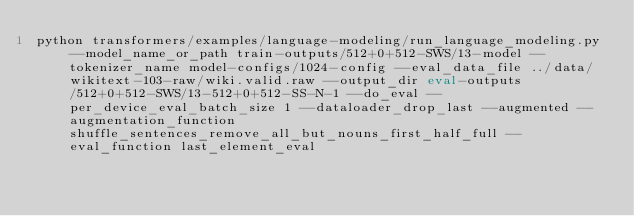<code> <loc_0><loc_0><loc_500><loc_500><_Bash_>python transformers/examples/language-modeling/run_language_modeling.py --model_name_or_path train-outputs/512+0+512-SWS/13-model --tokenizer_name model-configs/1024-config --eval_data_file ../data/wikitext-103-raw/wiki.valid.raw --output_dir eval-outputs/512+0+512-SWS/13-512+0+512-SS-N-1 --do_eval --per_device_eval_batch_size 1 --dataloader_drop_last --augmented --augmentation_function shuffle_sentences_remove_all_but_nouns_first_half_full --eval_function last_element_eval</code> 